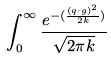Convert formula to latex. <formula><loc_0><loc_0><loc_500><loc_500>\int _ { 0 } ^ { \infty } \frac { e ^ { - ( \frac { ( q \cdot g ) ^ { 2 } } { 2 k } ) } } { \sqrt { 2 \pi k } }</formula> 